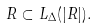Convert formula to latex. <formula><loc_0><loc_0><loc_500><loc_500>R \subset L _ { \Delta } ( | R | ) .</formula> 